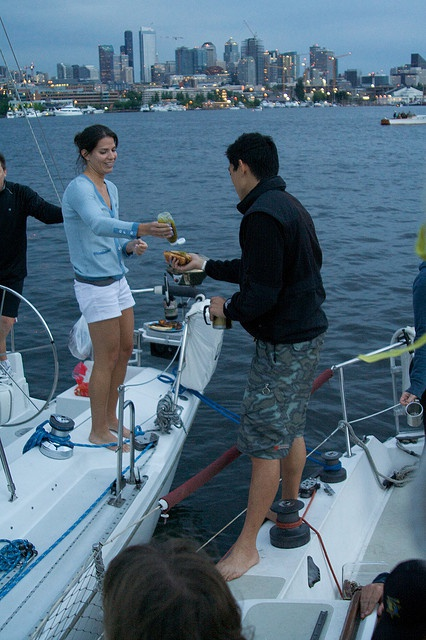Describe the objects in this image and their specific colors. I can see boat in darkgray, lightblue, blue, and gray tones, boat in darkgray, lightblue, and gray tones, people in darkgray, black, gray, blue, and darkblue tones, people in darkgray, gray, and lightblue tones, and people in darkgray, black, gray, and purple tones in this image. 